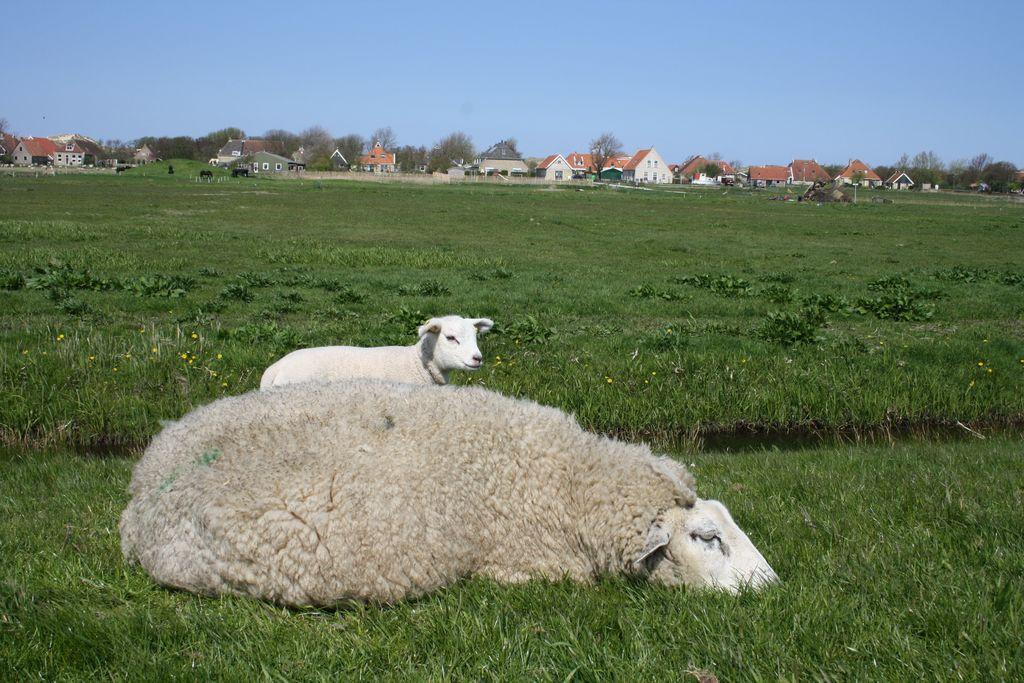Can you describe this image briefly? In this picture I can see a sheep and a lamb at the bottom. In the background there are buildings and trees, at the top there is the sky. 